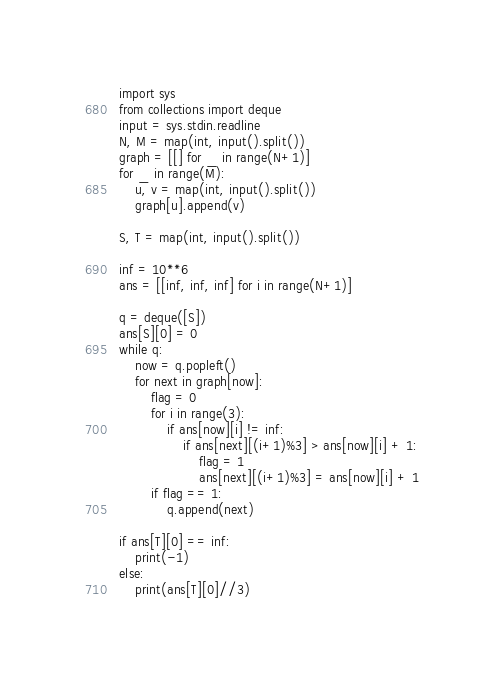Convert code to text. <code><loc_0><loc_0><loc_500><loc_500><_Python_>import sys
from collections import deque
input = sys.stdin.readline
N, M = map(int, input().split())
graph = [[] for _ in range(N+1)]
for _ in range(M):
    u, v = map(int, input().split())
    graph[u].append(v)

S, T = map(int, input().split())

inf = 10**6
ans = [[inf, inf, inf] for i in range(N+1)]

q = deque([S])
ans[S][0] = 0
while q:
    now = q.popleft()
    for next in graph[now]:
        flag = 0
        for i in range(3):
            if ans[now][i] != inf:
                if ans[next][(i+1)%3] > ans[now][i] + 1:
                    flag = 1
                    ans[next][(i+1)%3] = ans[now][i] + 1
        if flag == 1:
            q.append(next)

if ans[T][0] == inf:
    print(-1)
else:
    print(ans[T][0]//3)
</code> 